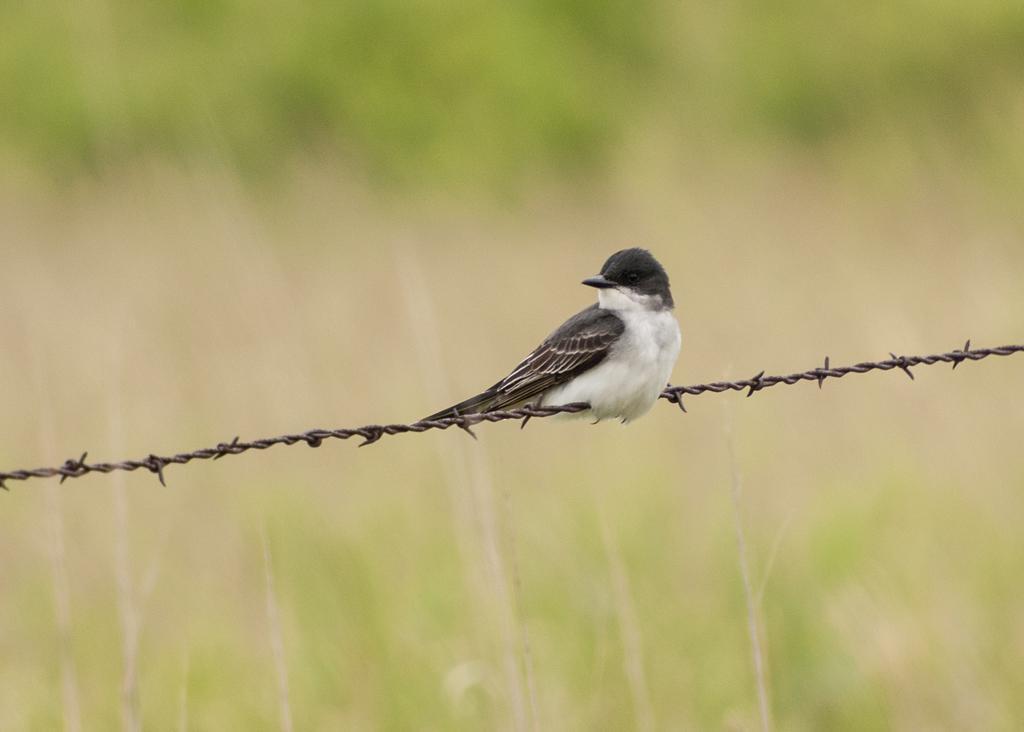In one or two sentences, can you explain what this image depicts? In the picture I can see a bird on the metal wire. It is looking like a green grass at the top and at the bottom of the picture. 